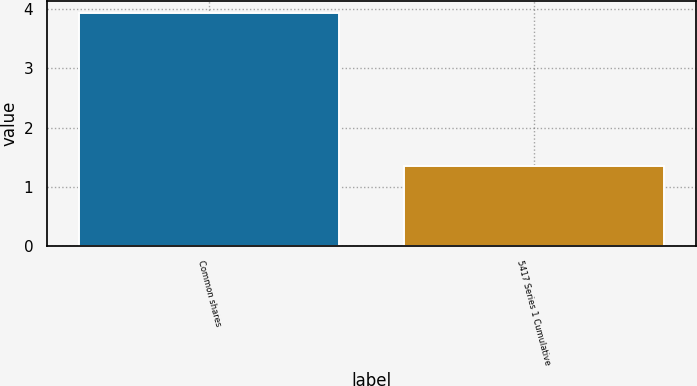Convert chart to OTSL. <chart><loc_0><loc_0><loc_500><loc_500><bar_chart><fcel>Common shares<fcel>5417 Series 1 Cumulative<nl><fcel>3.94<fcel>1.35<nl></chart> 